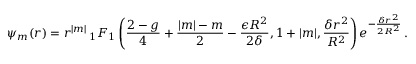<formula> <loc_0><loc_0><loc_500><loc_500>\psi _ { m } ( r ) = r ^ { | m | } \, _ { 1 } F _ { 1 } \left ( { \frac { 2 - g } { 4 } } + { \frac { | m | - m } { 2 } } - { \frac { \epsilon R ^ { 2 } } { 2 \delta } } , 1 + | m | , { \frac { \delta r ^ { 2 } } { R ^ { 2 } } } \right ) e ^ { - { \frac { \delta r ^ { 2 } } { 2 R ^ { 2 } } } } \, .</formula> 